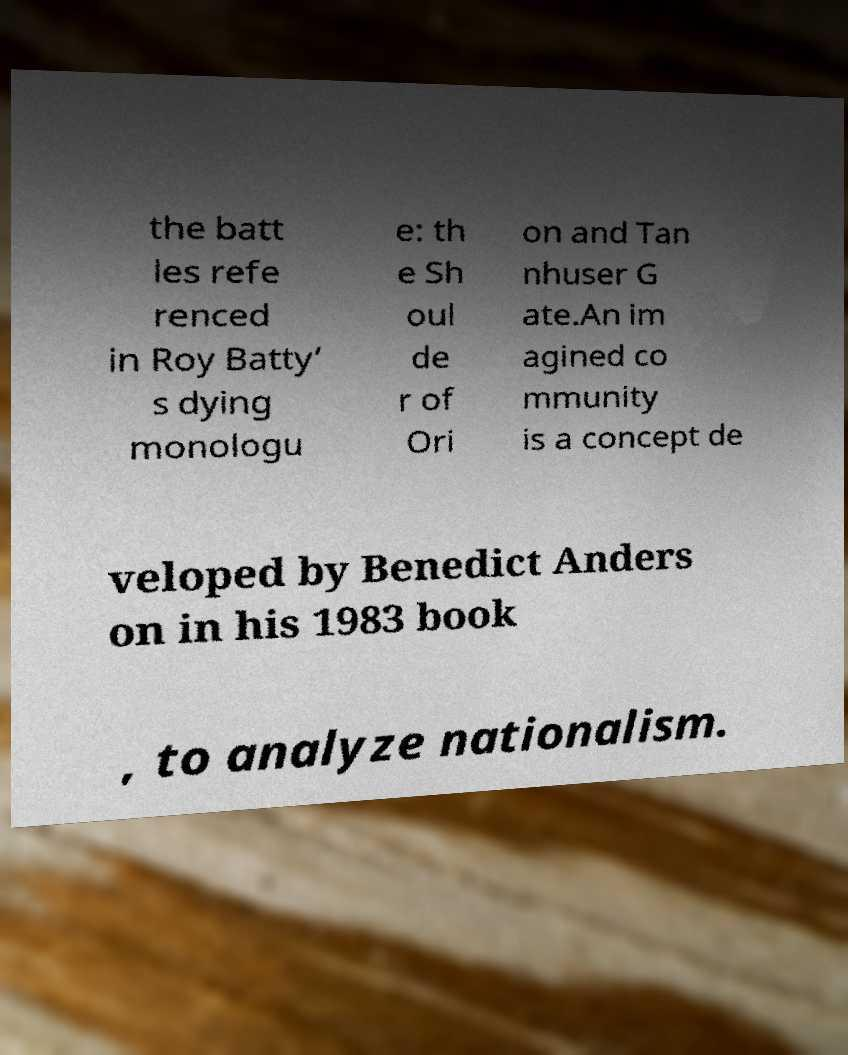Could you extract and type out the text from this image? the batt les refe renced in Roy Batty’ s dying monologu e: th e Sh oul de r of Ori on and Tan nhuser G ate.An im agined co mmunity is a concept de veloped by Benedict Anders on in his 1983 book , to analyze nationalism. 